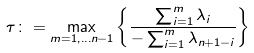Convert formula to latex. <formula><loc_0><loc_0><loc_500><loc_500>\tau \colon = \max _ { m = 1 , \dots n - 1 } \left \{ \frac { \sum _ { i = 1 } ^ { m } \lambda _ { i } } { - \sum _ { i = 1 } ^ { m } \lambda _ { n + 1 - i } } \right \}</formula> 